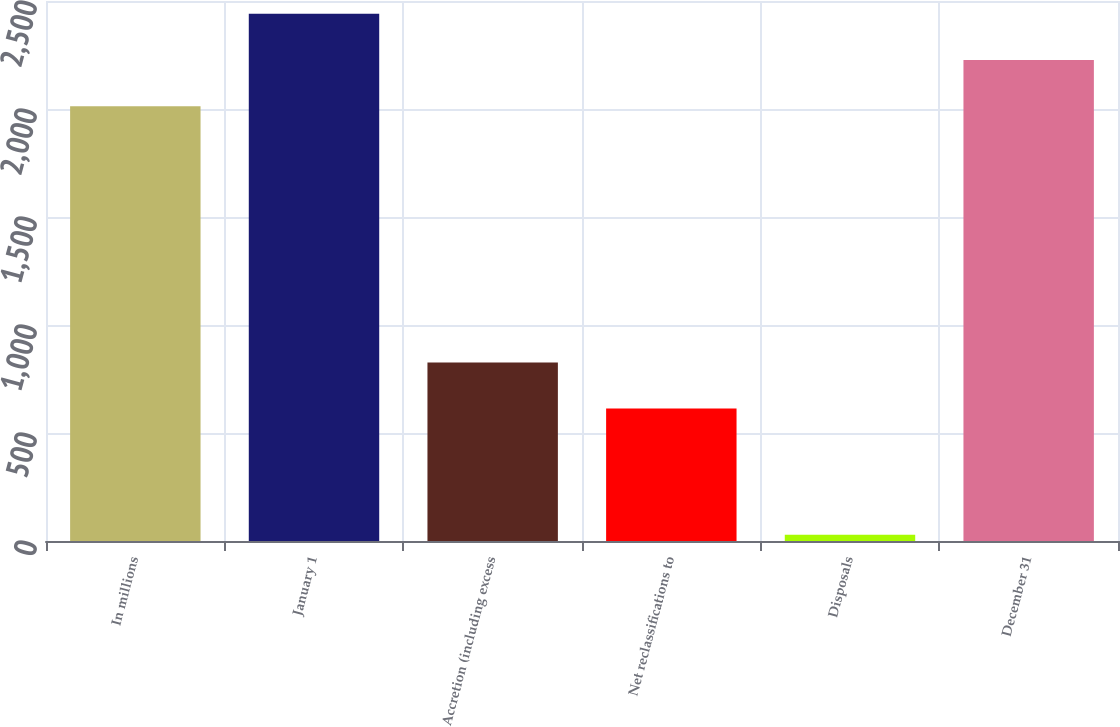<chart> <loc_0><loc_0><loc_500><loc_500><bar_chart><fcel>In millions<fcel>January 1<fcel>Accretion (including excess<fcel>Net reclassifications to<fcel>Disposals<fcel>December 31<nl><fcel>2013<fcel>2440.4<fcel>826.7<fcel>613<fcel>29<fcel>2226.7<nl></chart> 